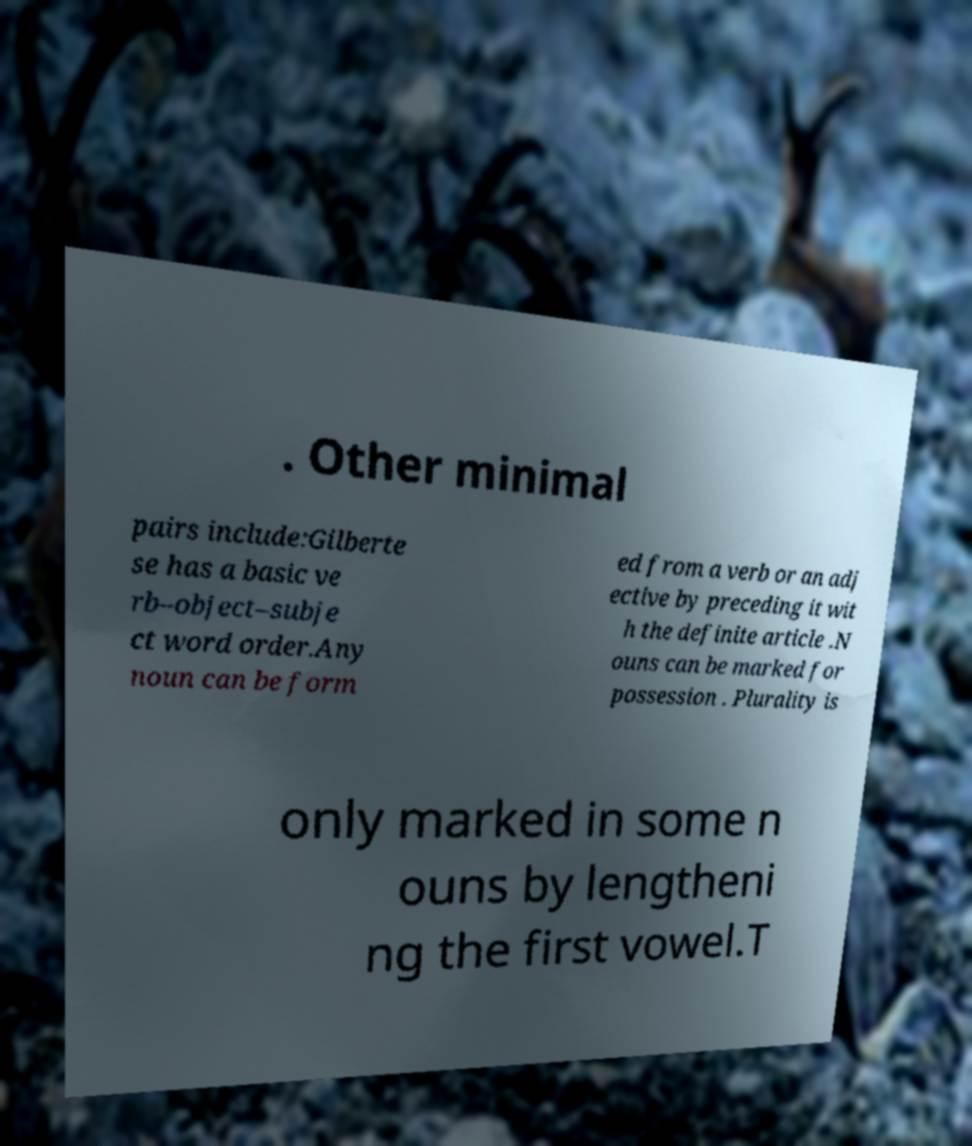For documentation purposes, I need the text within this image transcribed. Could you provide that? . Other minimal pairs include:Gilberte se has a basic ve rb–object–subje ct word order.Any noun can be form ed from a verb or an adj ective by preceding it wit h the definite article .N ouns can be marked for possession . Plurality is only marked in some n ouns by lengtheni ng the first vowel.T 